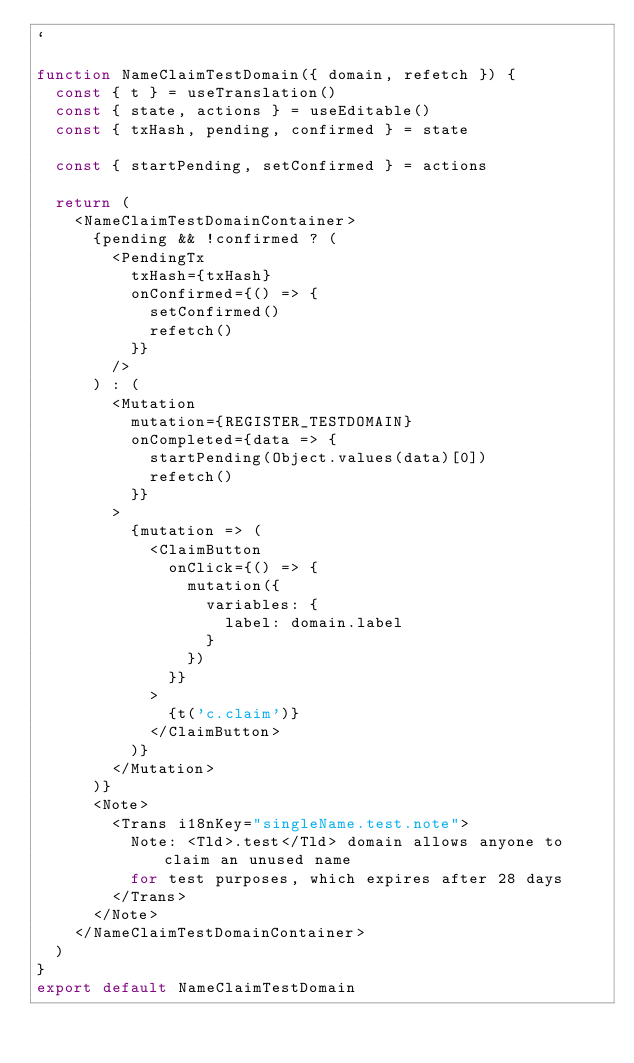Convert code to text. <code><loc_0><loc_0><loc_500><loc_500><_JavaScript_>`

function NameClaimTestDomain({ domain, refetch }) {
  const { t } = useTranslation()
  const { state, actions } = useEditable()
  const { txHash, pending, confirmed } = state

  const { startPending, setConfirmed } = actions

  return (
    <NameClaimTestDomainContainer>
      {pending && !confirmed ? (
        <PendingTx
          txHash={txHash}
          onConfirmed={() => {
            setConfirmed()
            refetch()
          }}
        />
      ) : (
        <Mutation
          mutation={REGISTER_TESTDOMAIN}
          onCompleted={data => {
            startPending(Object.values(data)[0])
            refetch()
          }}
        >
          {mutation => (
            <ClaimButton
              onClick={() => {
                mutation({
                  variables: {
                    label: domain.label
                  }
                })
              }}
            >
              {t('c.claim')}
            </ClaimButton>
          )}
        </Mutation>
      )}
      <Note>
        <Trans i18nKey="singleName.test.note">
          Note: <Tld>.test</Tld> domain allows anyone to claim an unused name
          for test purposes, which expires after 28 days
        </Trans>
      </Note>
    </NameClaimTestDomainContainer>
  )
}
export default NameClaimTestDomain
</code> 